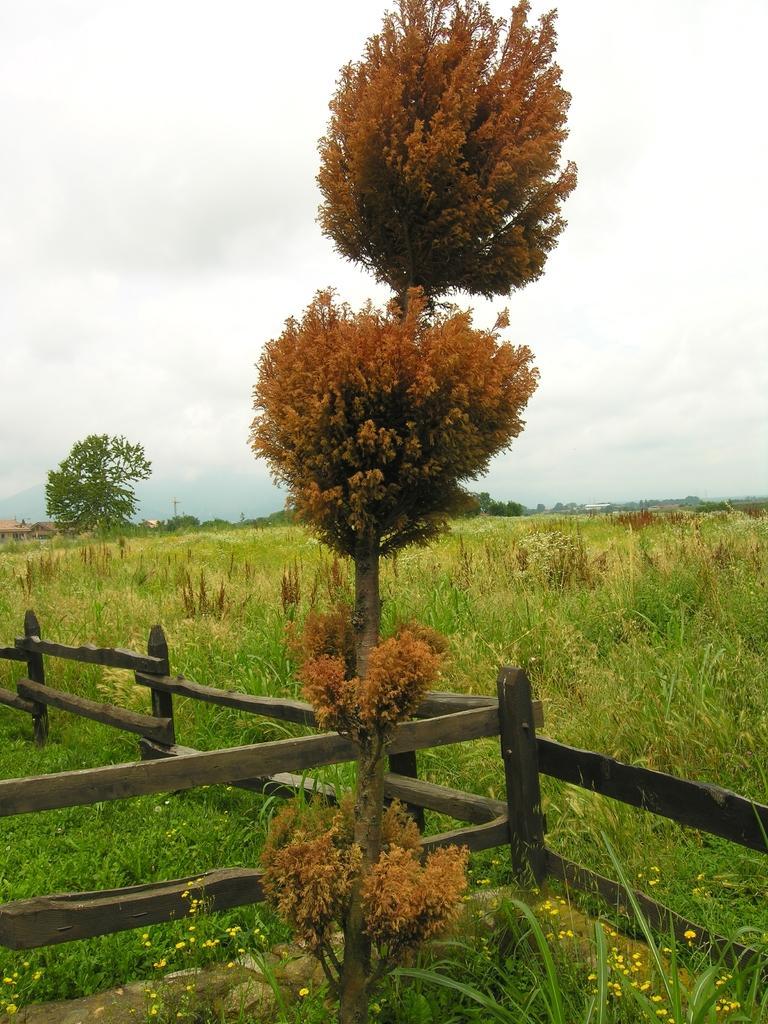How would you summarize this image in a sentence or two? In this picture I can see the brown color plant near to the wooden fencing. In the background I can see the farm land, plants, grass, trees, poles and building. In the top left I can see the sky and clouds. 